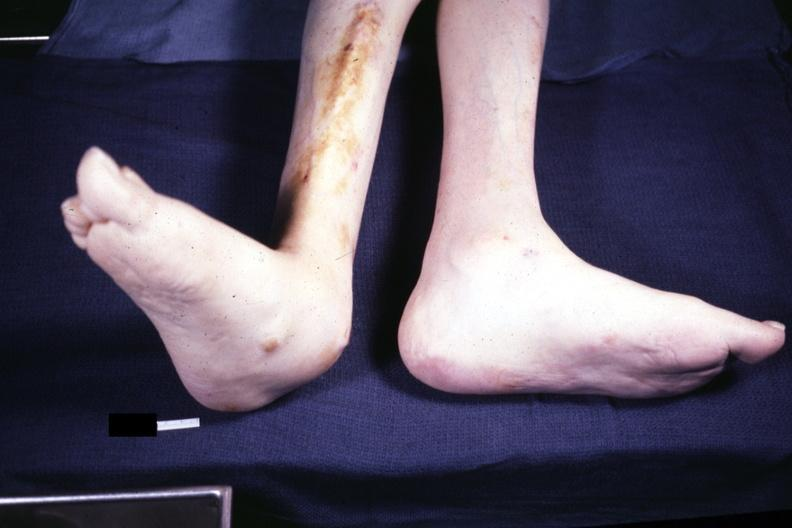re extremities present?
Answer the question using a single word or phrase. Yes 